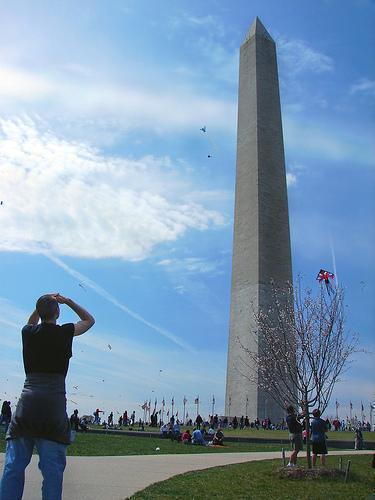What kind of people visit this place throughout the year?
Indicate the correct response by choosing from the four available options to answer the question.
Options: Worshippers, politicians, tourists, athletes. Tourists. 